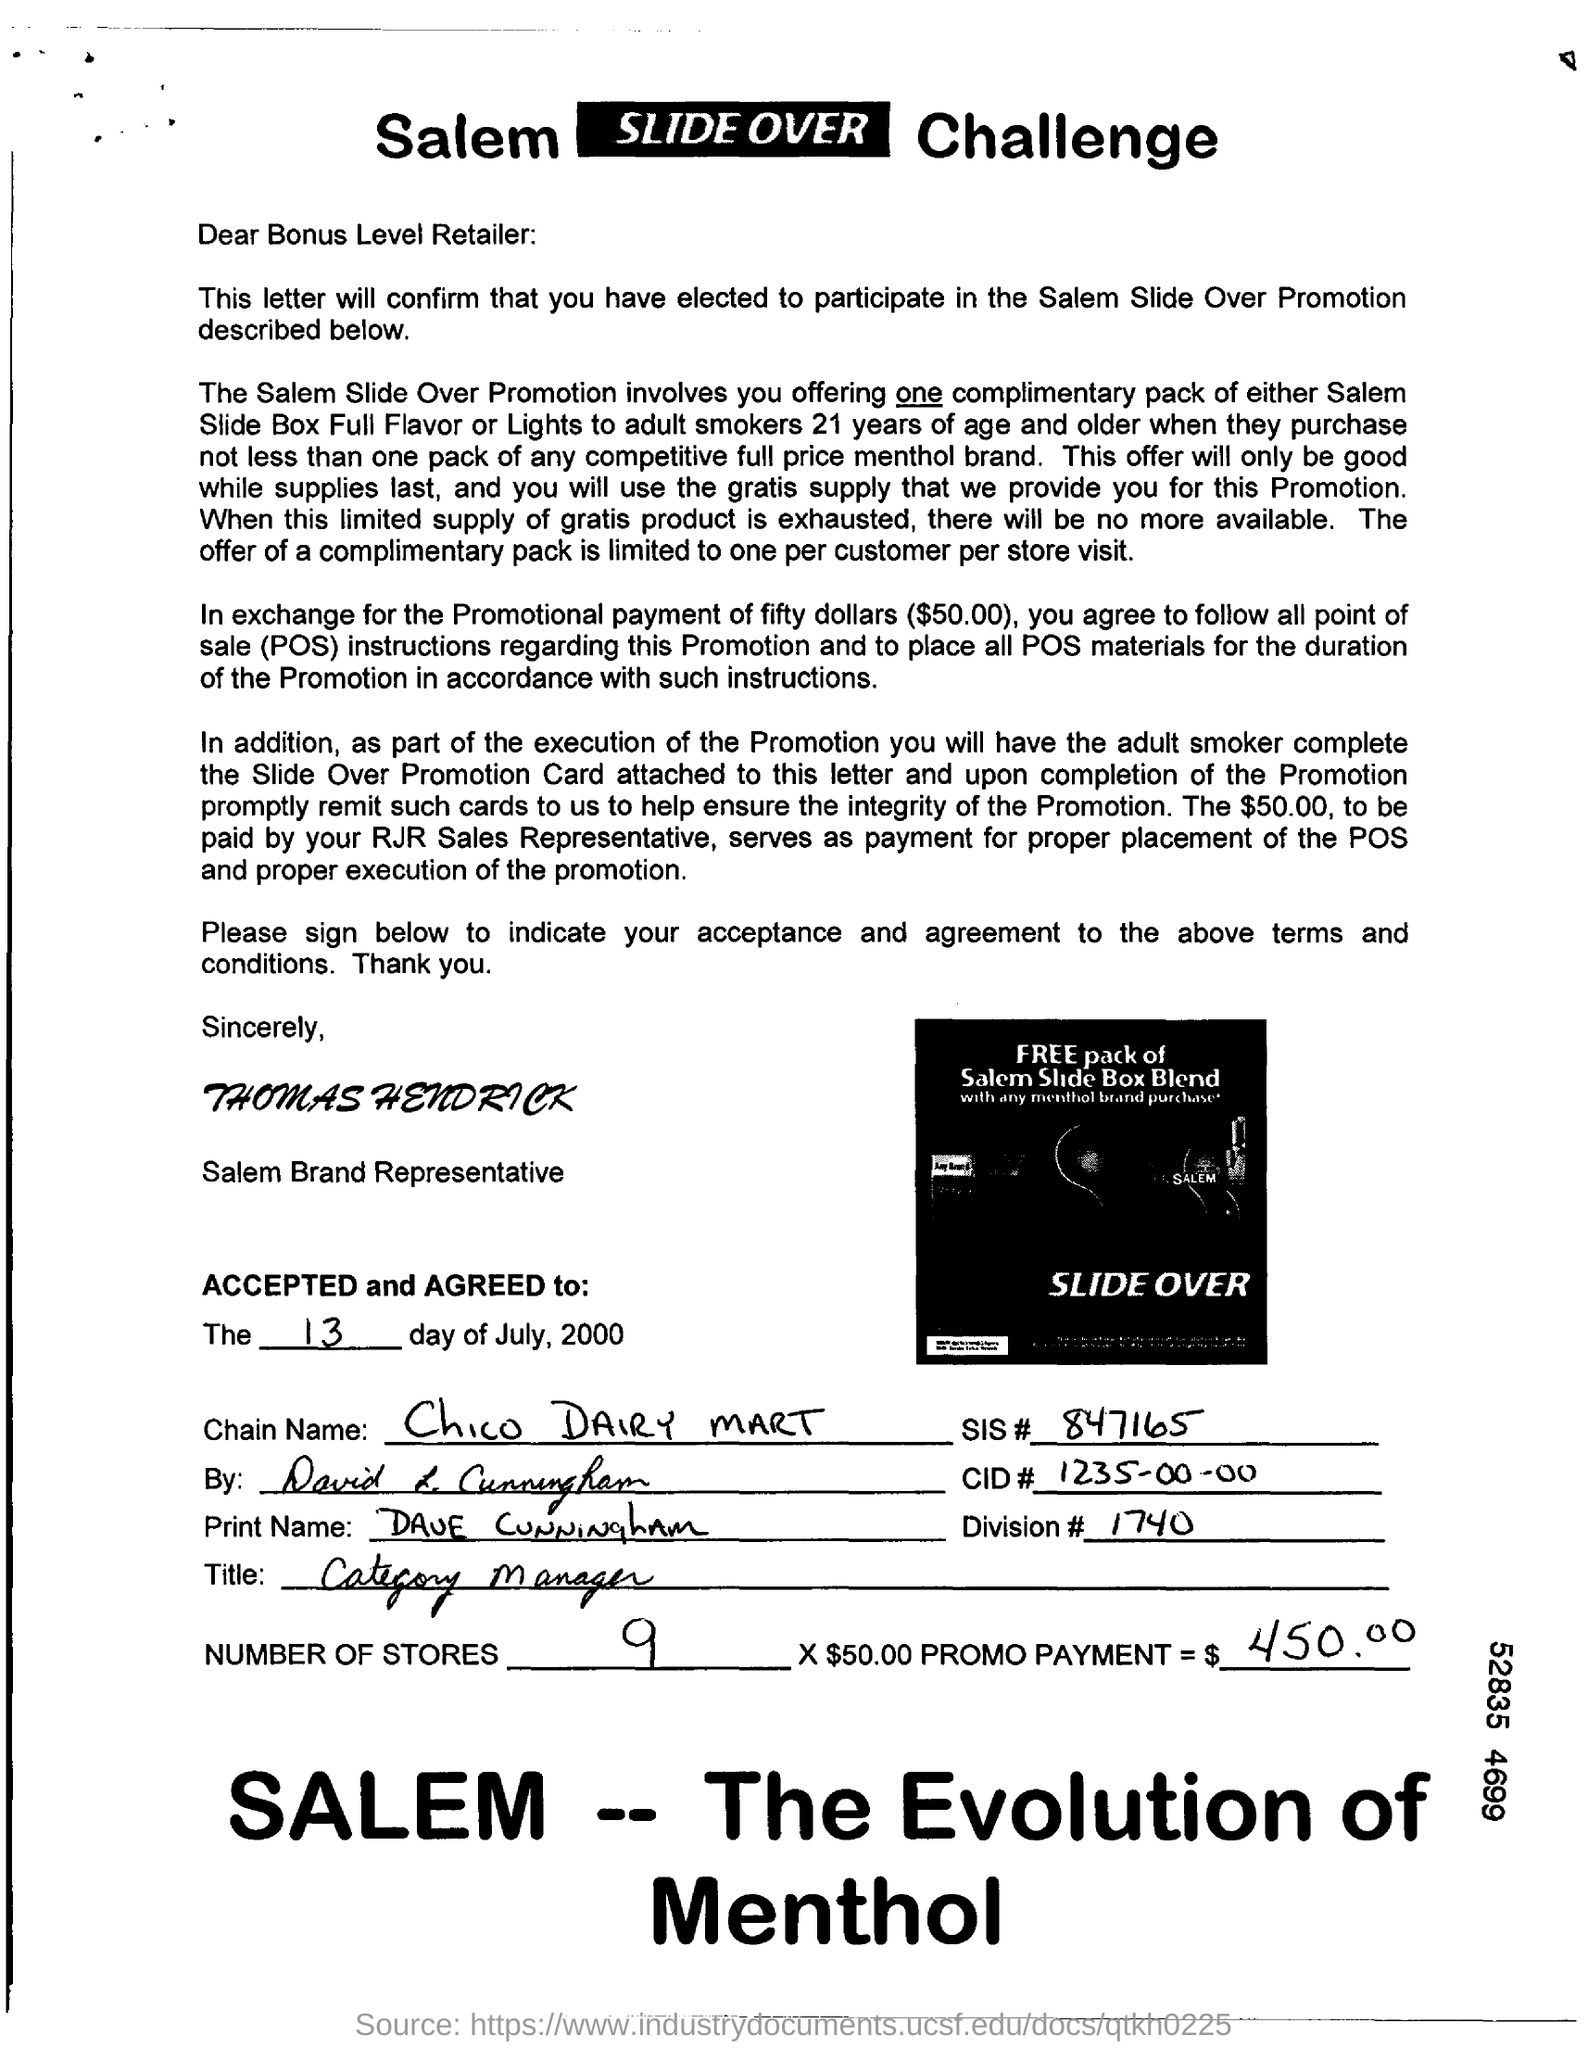What is the Chain Name?
Keep it short and to the point. Chico DAIRY MART. What is SIS#?
Your answer should be very brief. 847165. What is CID#?
Offer a very short reply. 1235-00-00. What is the number of stores mentioned in the document?
Ensure brevity in your answer.  9. 